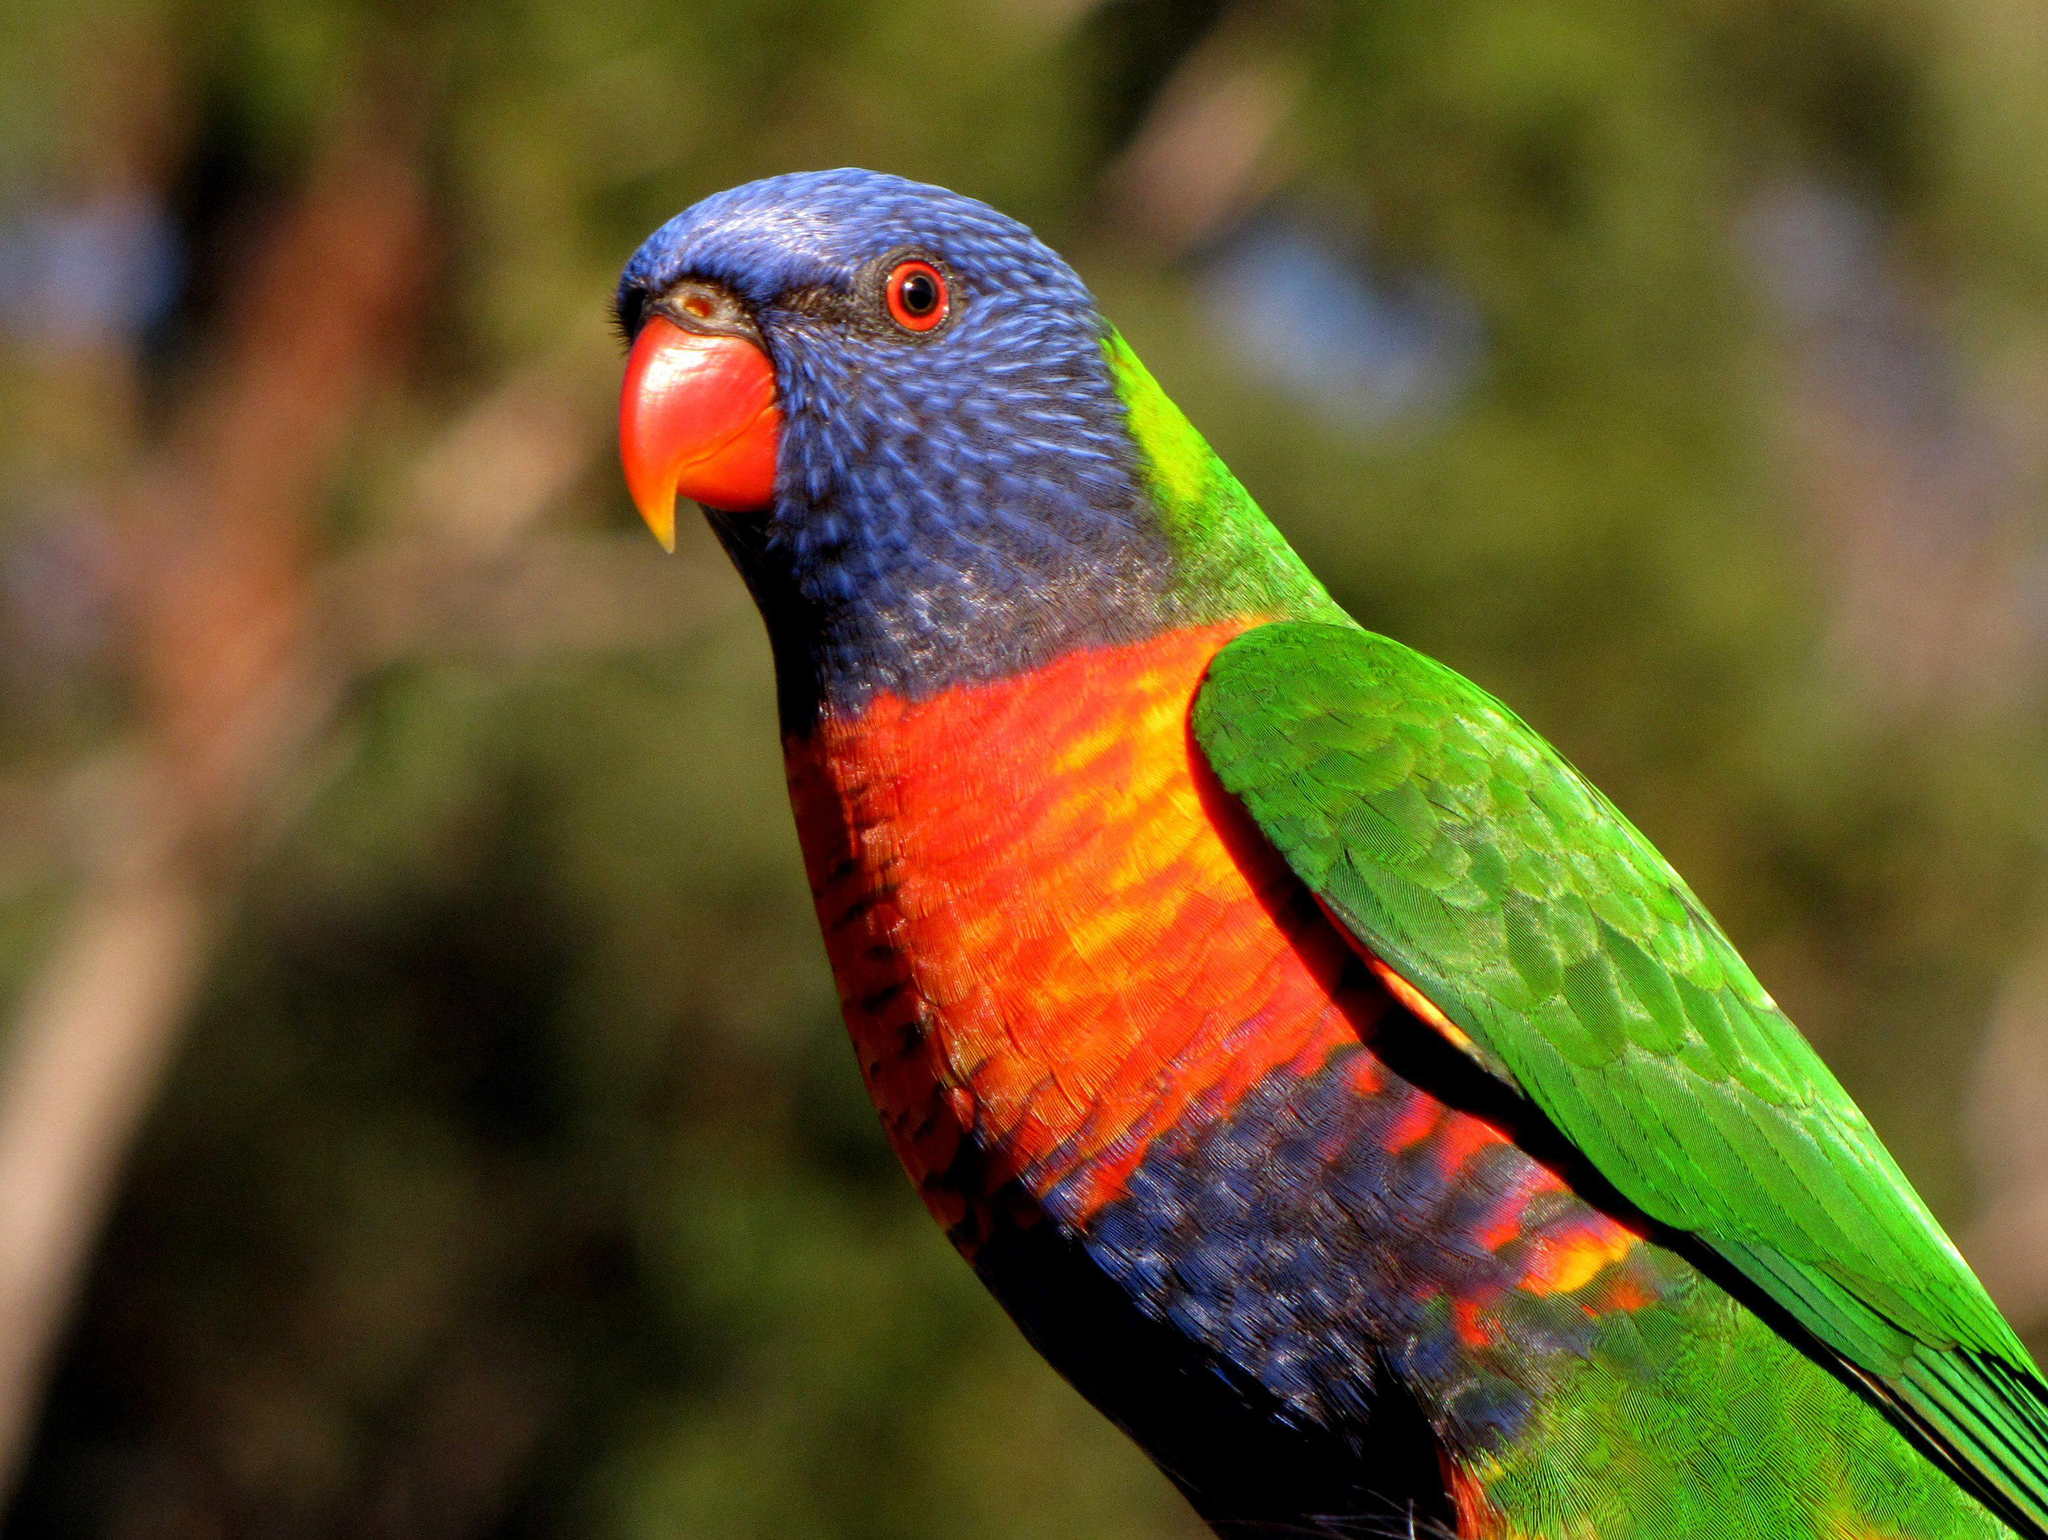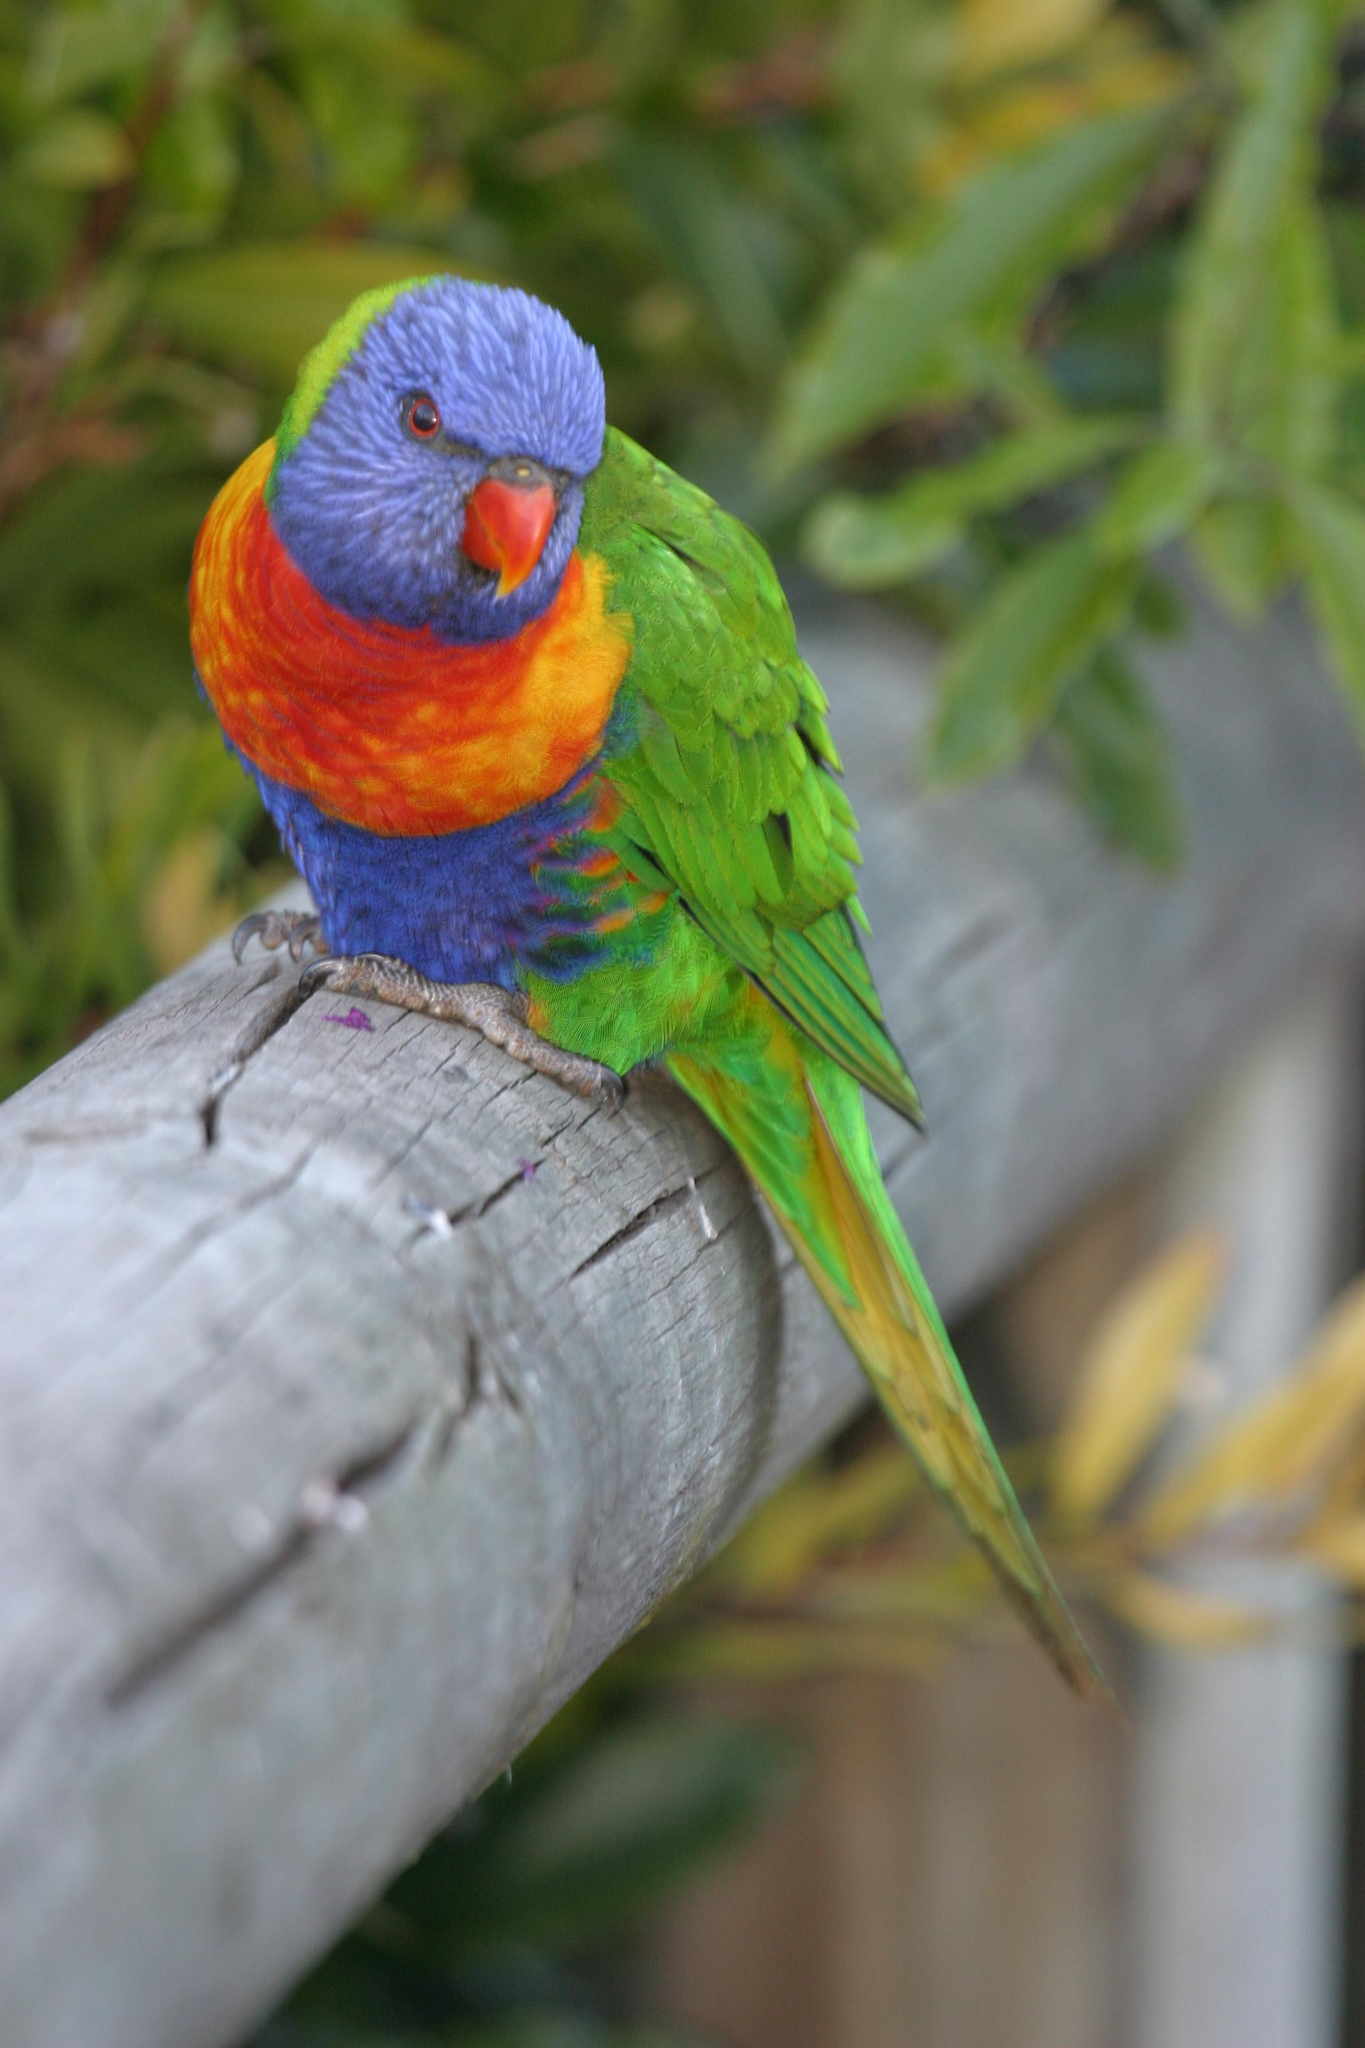The first image is the image on the left, the second image is the image on the right. Given the left and right images, does the statement "At least one parrot is perched on a human hand." hold true? Answer yes or no. No. The first image is the image on the left, the second image is the image on the right. Evaluate the accuracy of this statement regarding the images: "The left image contains at least two parrots.". Is it true? Answer yes or no. No. 